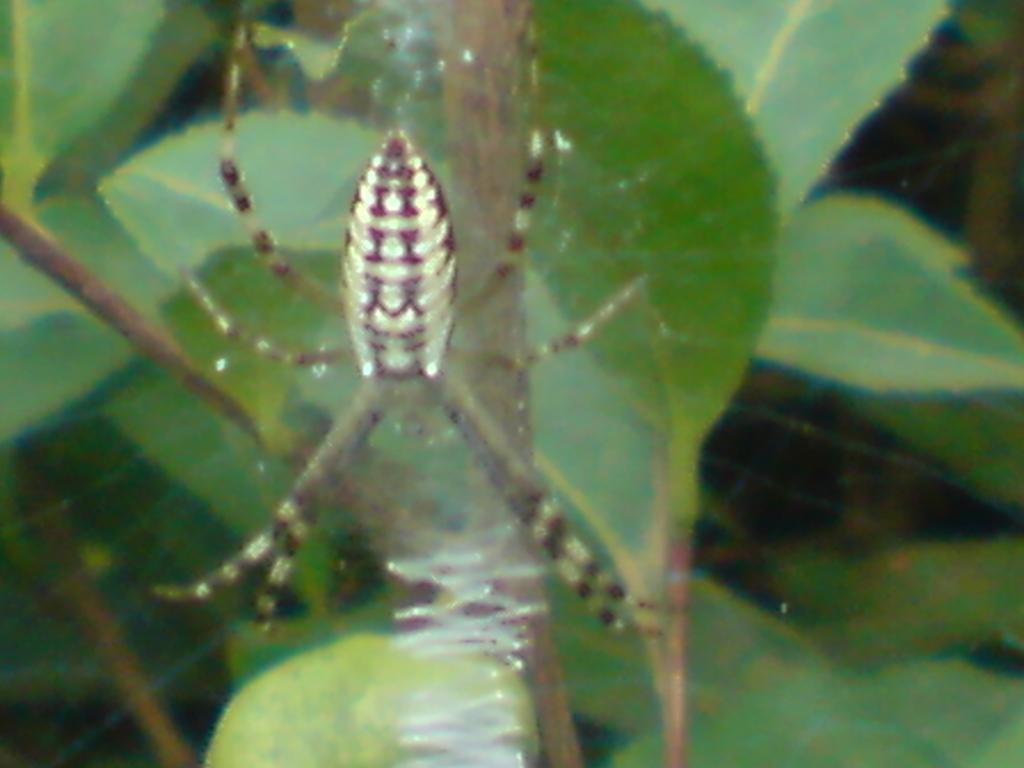In one or two sentences, can you explain what this image depicts? In the center of the image we can see a spider. In the background there are leaves. 